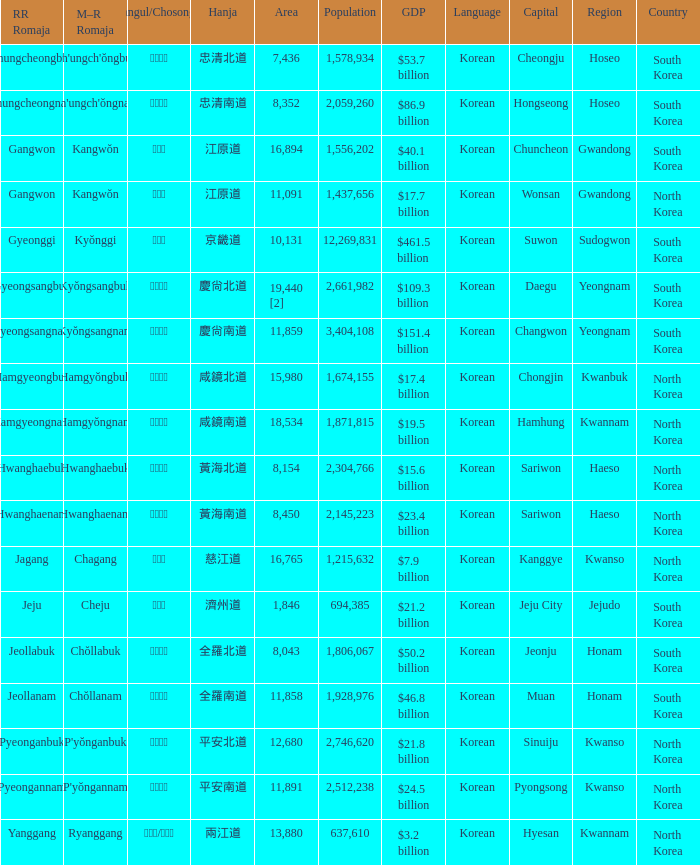What is the area for the province having Hangul of 경기도? 10131.0. 